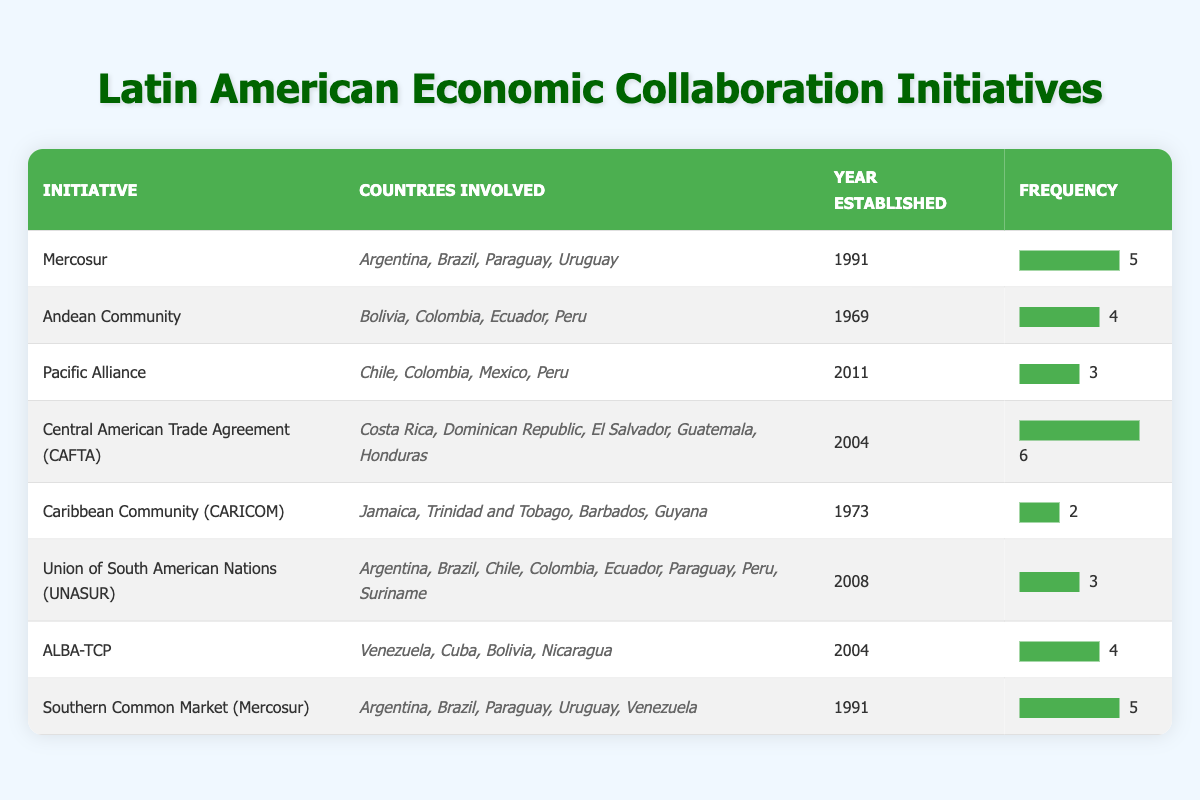What is the year of establishment for CAFTA? The year of establishment for the Central American Trade Agreement (CAFTA) is listed in the table, where it is clearly stated next to the initiative's name.
Answer: 2004 How many countries are involved in the Caribbean Community (CARICOM)? The table shows the countries involved in each initiative. For the Caribbean Community (CARICOM), it lists four countries: Jamaica, Trinidad and Tobago, Barbados, and Guyana.
Answer: 4 Which initiative has the highest frequency of economic collaboration? By inspecting the "Frequency" column, it's clear that the Central American Trade Agreement (CAFTA) has the highest frequency at 6.
Answer: 6 Is ALBA-TCP established before the Pacific Alliance? The table provides the years for both initiatives. ALBA-TCP was established in 2004, while the Pacific Alliance was established in 2011, indicating that ALBA-TCP was established before the Pacific Alliance.
Answer: Yes What is the total frequency of initiatives that involve Argentina? The initiatives involving Argentina are Mercosur (frequency 5) and Southern Common Market (Mercosur) (frequency 5). Summing these gives a total frequency of 10.
Answer: 10 How many initiatives have a frequency of 3? The table indicates that there are three initiatives with a frequency of 3. They are the Pacific Alliance, Union of South American Nations (UNASUR), and another one noted in the table.
Answer: 3 What is the average frequency of all the initiatives listed? To find the average, sum all frequencies: (5 + 4 + 3 + 6 + 2 + 3 + 4 + 5) = 32. There are 8 initiatives, so the average is 32 / 8 = 4.
Answer: 4 Is there an initiative that has a frequency of 2 and was established after 2000? The Caribbean Community (CARICOM) has a frequency of 2 and was established in 1973, while all other initiatives with a frequency of 2 were established before 2000. Therefore, there are no initiatives with a frequency of 2 established after 2000.
Answer: No Which countries are involved in the Andean Community? The table explicitly lists the countries involved in the Andean Community as Bolivia, Colombia, Ecuador, and Peru.
Answer: Bolivia, Colombia, Ecuador, Peru 